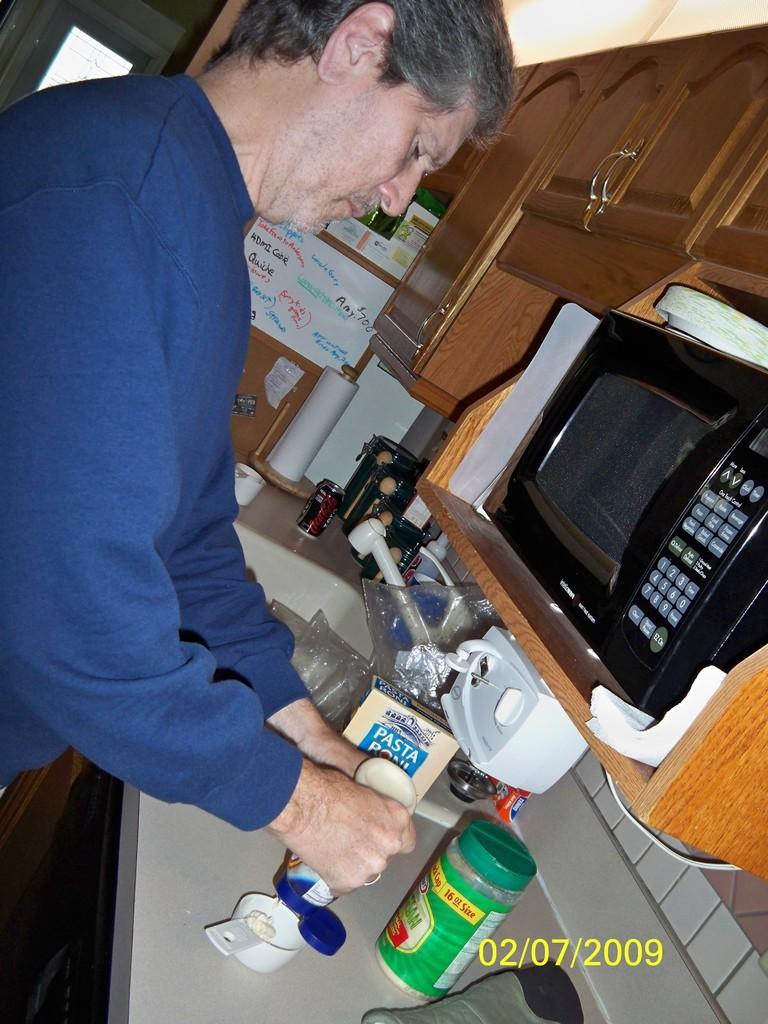In one or two sentences, can you explain what this image depicts? In this picture we can see a few bottles, containers, a tin, sink and other objects on the kitchen platform. We can see some numbers in the bottom right. There is an oven. We can see wooden cupboards. There is a person holding an object in the hand. 